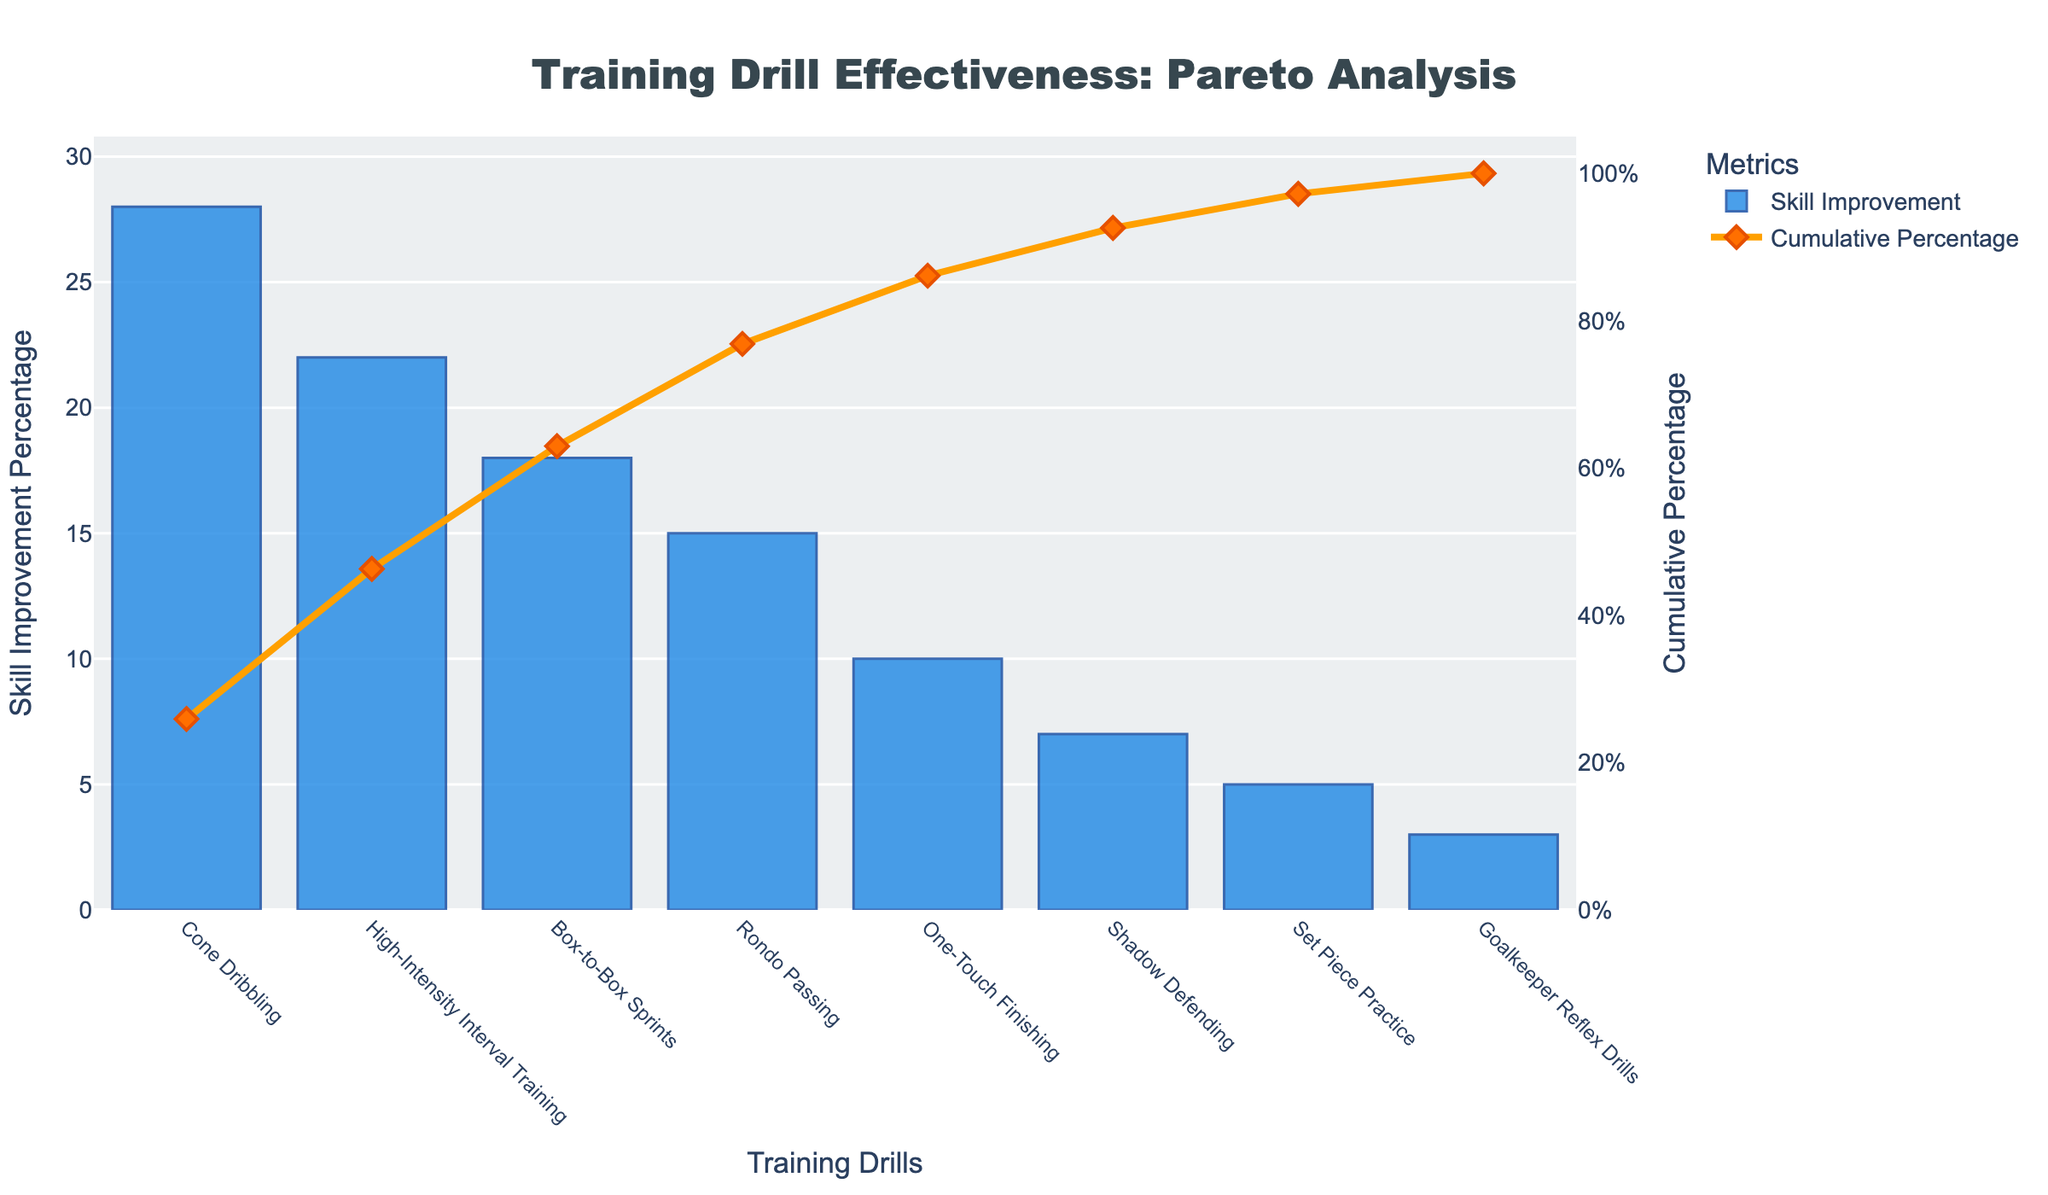What's the title of the chart? The chart title is usually placed at the top of the figure and is clearly visible.
Answer: Training Drill Effectiveness: Pareto Analysis What is the highest Skill Improvement Percentage? To find the highest percentage, look at the tallest bar in the bar chart.
Answer: 28% Which drill contributed most to Skill Improvement? The drill with the highest Skill Improvement Percentage is represented by the tallest bar on the chart.
Answer: Cone Dribbling What is the cumulative percentage after the first two drills? Sum the Skill Improvement Percentages of the first two drills and then check the cumulative percentage on the line graph. Cone Dribbling (28%) + High-Intensity Interval Training (22%) = 50%.
Answer: 50% Which drill has the lowest Skill Improvement Percentage? The lowest Skill Improvement Percentage is represented by the shortest bar in the bar chart.
Answer: Goalkeeper Reflex Drills How many drills show a Skill Improvement Percentage greater than 10%? Count the number of bars that have a height representing a Skill Improvement Percentage greater than 10%.
Answer: 4 What cumulative percentage is reached after adding the top three drills? Add the Skill Improvement Percentages of the top three drills: Cone Dribbling (28%) + High-Intensity Interval Training (22%) + Box-to-Box Sprints (18%) = 68%.
Answer: 68% What is the Skill Improvement Percentage of Rondo Passing? Locate the bar labeled Rondo Passing and read the value.
Answer: 15% Between Rondo Passing and One-Touch Finishing, which has a higher improvement percentage? Compare the heights of the bars associated with Rondo Passing and One-Touch Finishing.
Answer: Rondo Passing What is the total Skill Improvement Percentage of all drills combined? Sum all the Skill Improvement Percentages: (28 + 22 + 18 + 15 + 10 + 7 + 5 + 3)
Answer: 108% What cumulative percentage does Set Piece Practice contribute when added on? Identify the cumulative percentage just before Set Piece Practice and then add Set Piece Practice's contribution. Cumulative before Set Piece Practice is 100%, thus 100% + 5% = 105%.
Answer: 105% 